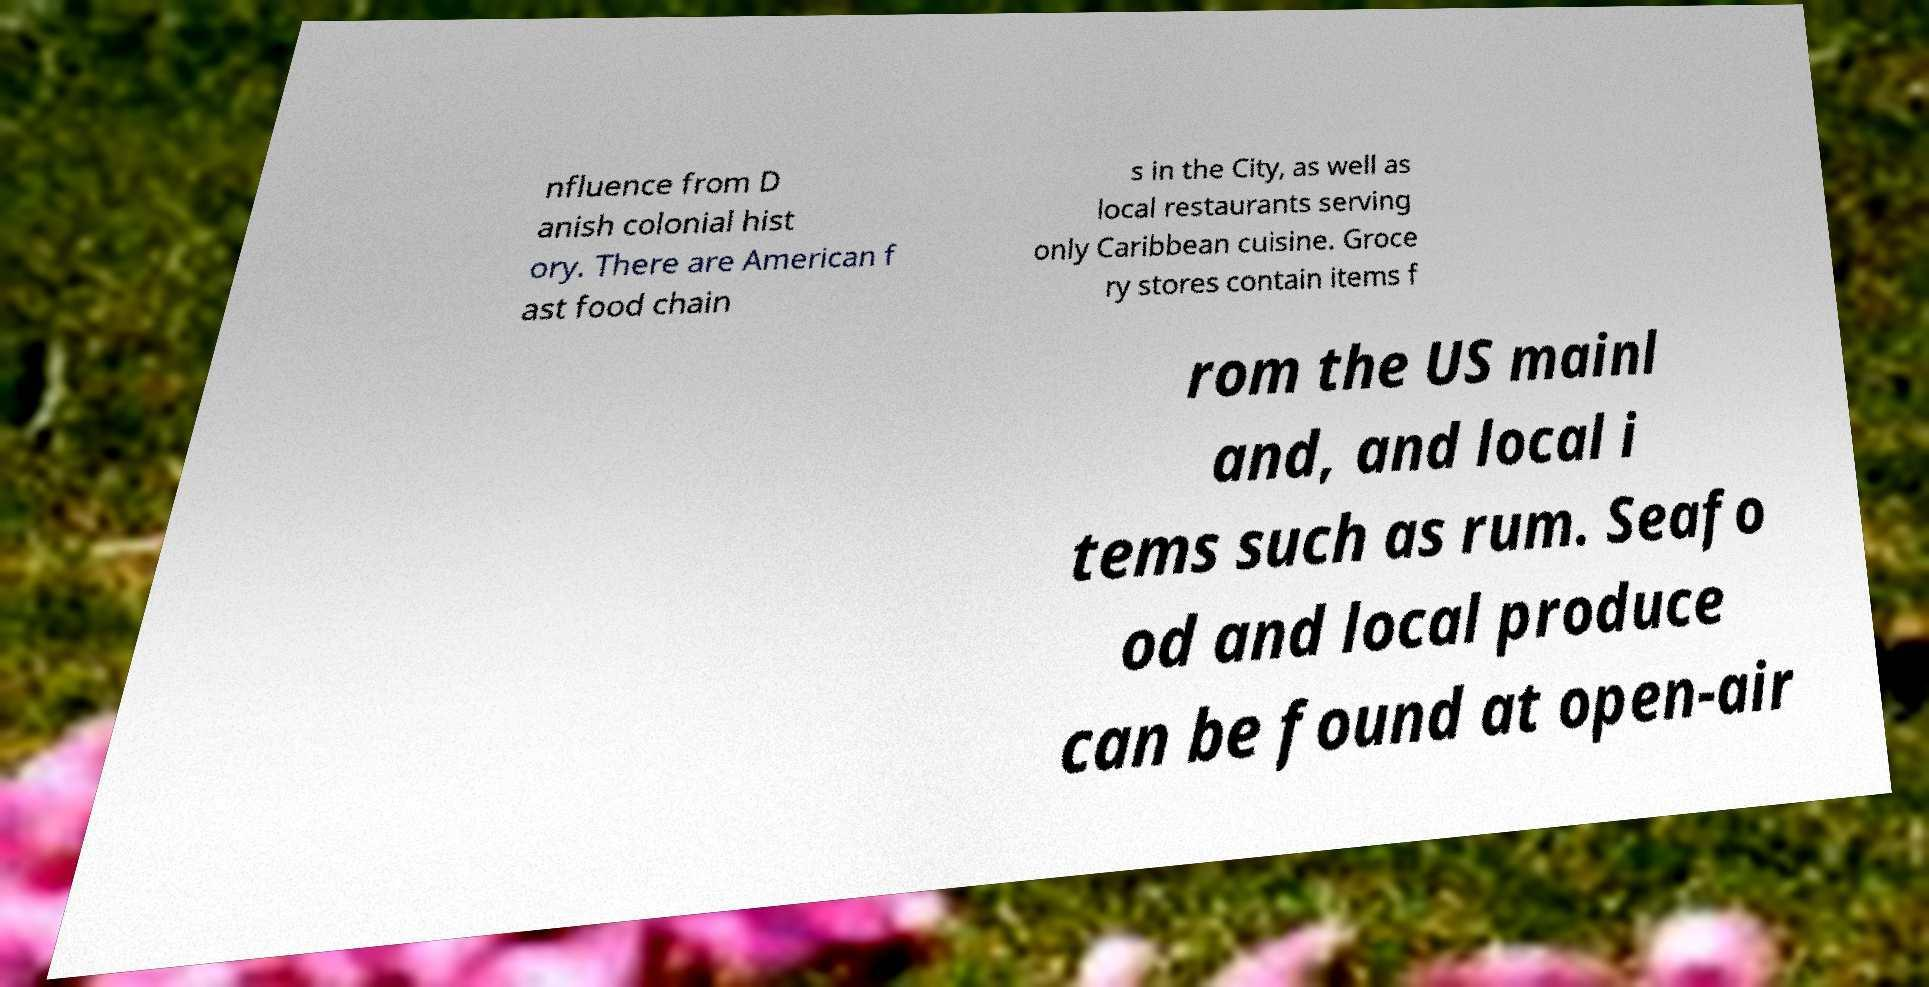Can you accurately transcribe the text from the provided image for me? nfluence from D anish colonial hist ory. There are American f ast food chain s in the City, as well as local restaurants serving only Caribbean cuisine. Groce ry stores contain items f rom the US mainl and, and local i tems such as rum. Seafo od and local produce can be found at open-air 